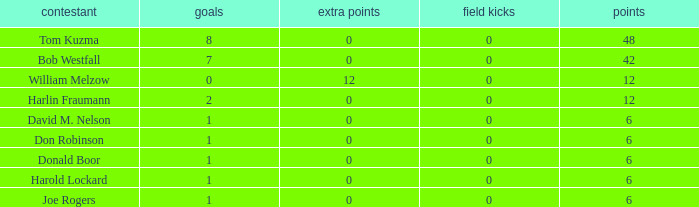Identify the scores for donald boor. 6.0. 